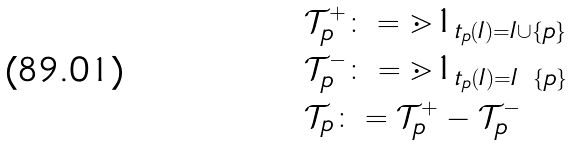<formula> <loc_0><loc_0><loc_500><loc_500>& \mathcal { T } _ { p } ^ { + } \colon = \mathbb { m } { 1 } _ { t _ { p } ( I ) = I \cup \{ p \} } \\ & \mathcal { T } _ { p } ^ { - } \colon = \mathbb { m } { 1 } _ { t _ { p } ( I ) = I \ \{ p \} } \\ & \mathcal { T } _ { p } \colon = \mathcal { T } _ { p } ^ { + } - \mathcal { T } _ { p } ^ { - }</formula> 